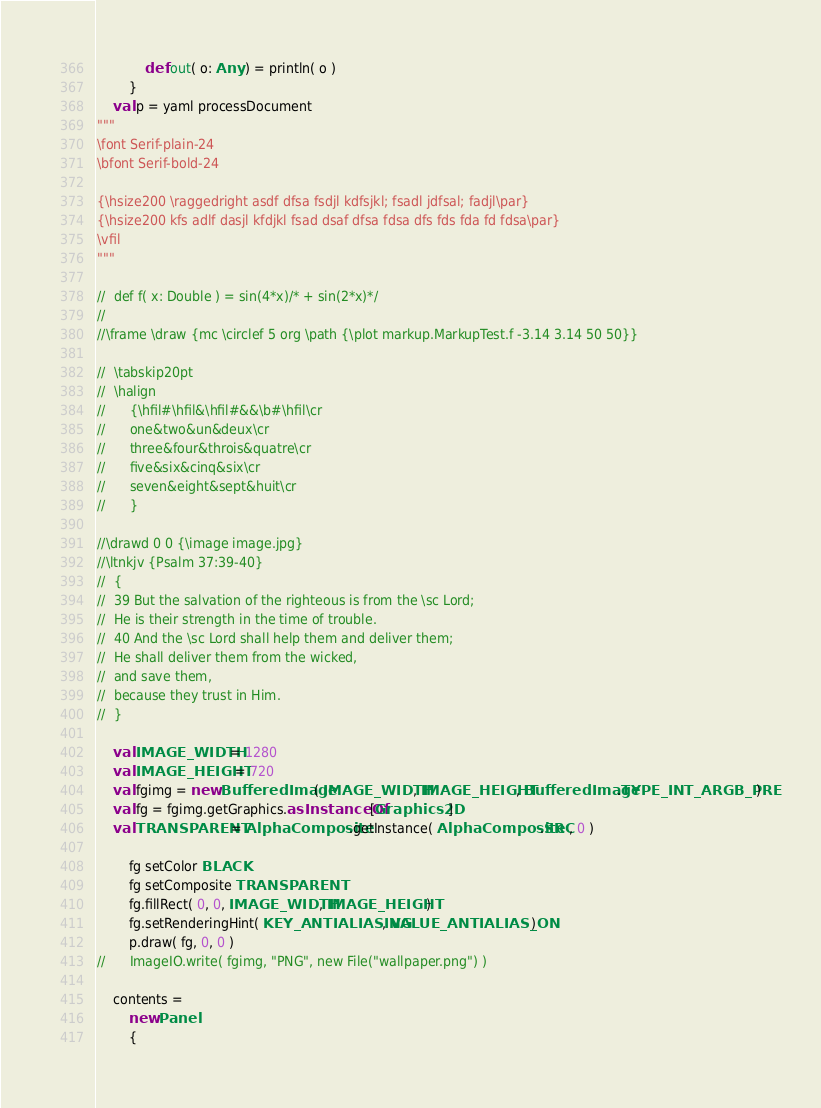<code> <loc_0><loc_0><loc_500><loc_500><_Scala_>			def out( o: Any ) = println( o )		
		}
	val p = yaml processDocument
"""
\font Serif-plain-24
\bfont Serif-bold-24

{\hsize200 \raggedright asdf dfsa fsdjl kdfsjkl; fsadl jdfsal; fadjl\par}
{\hsize200 kfs adlf dasjl kfdjkl fsad dsaf dfsa fdsa dfs fds fda fd fdsa\par}
\vfil
"""

//	def f( x: Double ) = sin(4*x)/* + sin(2*x)*/
//	
//\frame \draw {mc \circlef 5 org \path {\plot markup.MarkupTest.f -3.14 3.14 50 50}}

//	\tabskip20pt
//	\halign
//		{\hfil#\hfil&\hfil#&&\b#\hfil\cr
//		one&two&un&deux\cr
//		three&four&throis&quatre\cr
//		five&six&cinq&six\cr
//		seven&eight&sept&huit\cr
//		}

//\drawd 0 0 {\image image.jpg}
//\ltnkjv {Psalm 37:39-40}
//	{
//	39 But the salvation of the righteous is from the \sc Lord;
//	He is their strength in the time of trouble.
//	40 And the \sc Lord shall help them and deliver them;
//	He shall deliver them from the wicked,
//	and save them,
//	because they trust in Him.
//	}

	val IMAGE_WIDTH = 1280
	val IMAGE_HEIGHT = 720
	val fgimg = new BufferedImage( IMAGE_WIDTH, IMAGE_HEIGHT, BufferedImage.TYPE_INT_ARGB_PRE )
	val fg = fgimg.getGraphics.asInstanceOf[Graphics2D]
	val TRANSPARENT = AlphaComposite.getInstance( AlphaComposite.SRC, 0 )

		fg setColor BLACK
		fg setComposite TRANSPARENT
		fg.fillRect( 0, 0, IMAGE_WIDTH, IMAGE_HEIGHT )
		fg.setRenderingHint( KEY_ANTIALIASING, VALUE_ANTIALIAS_ON )
		p.draw( fg, 0, 0 )
//		ImageIO.write( fgimg, "PNG", new File("wallpaper.png") )

	contents =
		new Panel
		{</code> 